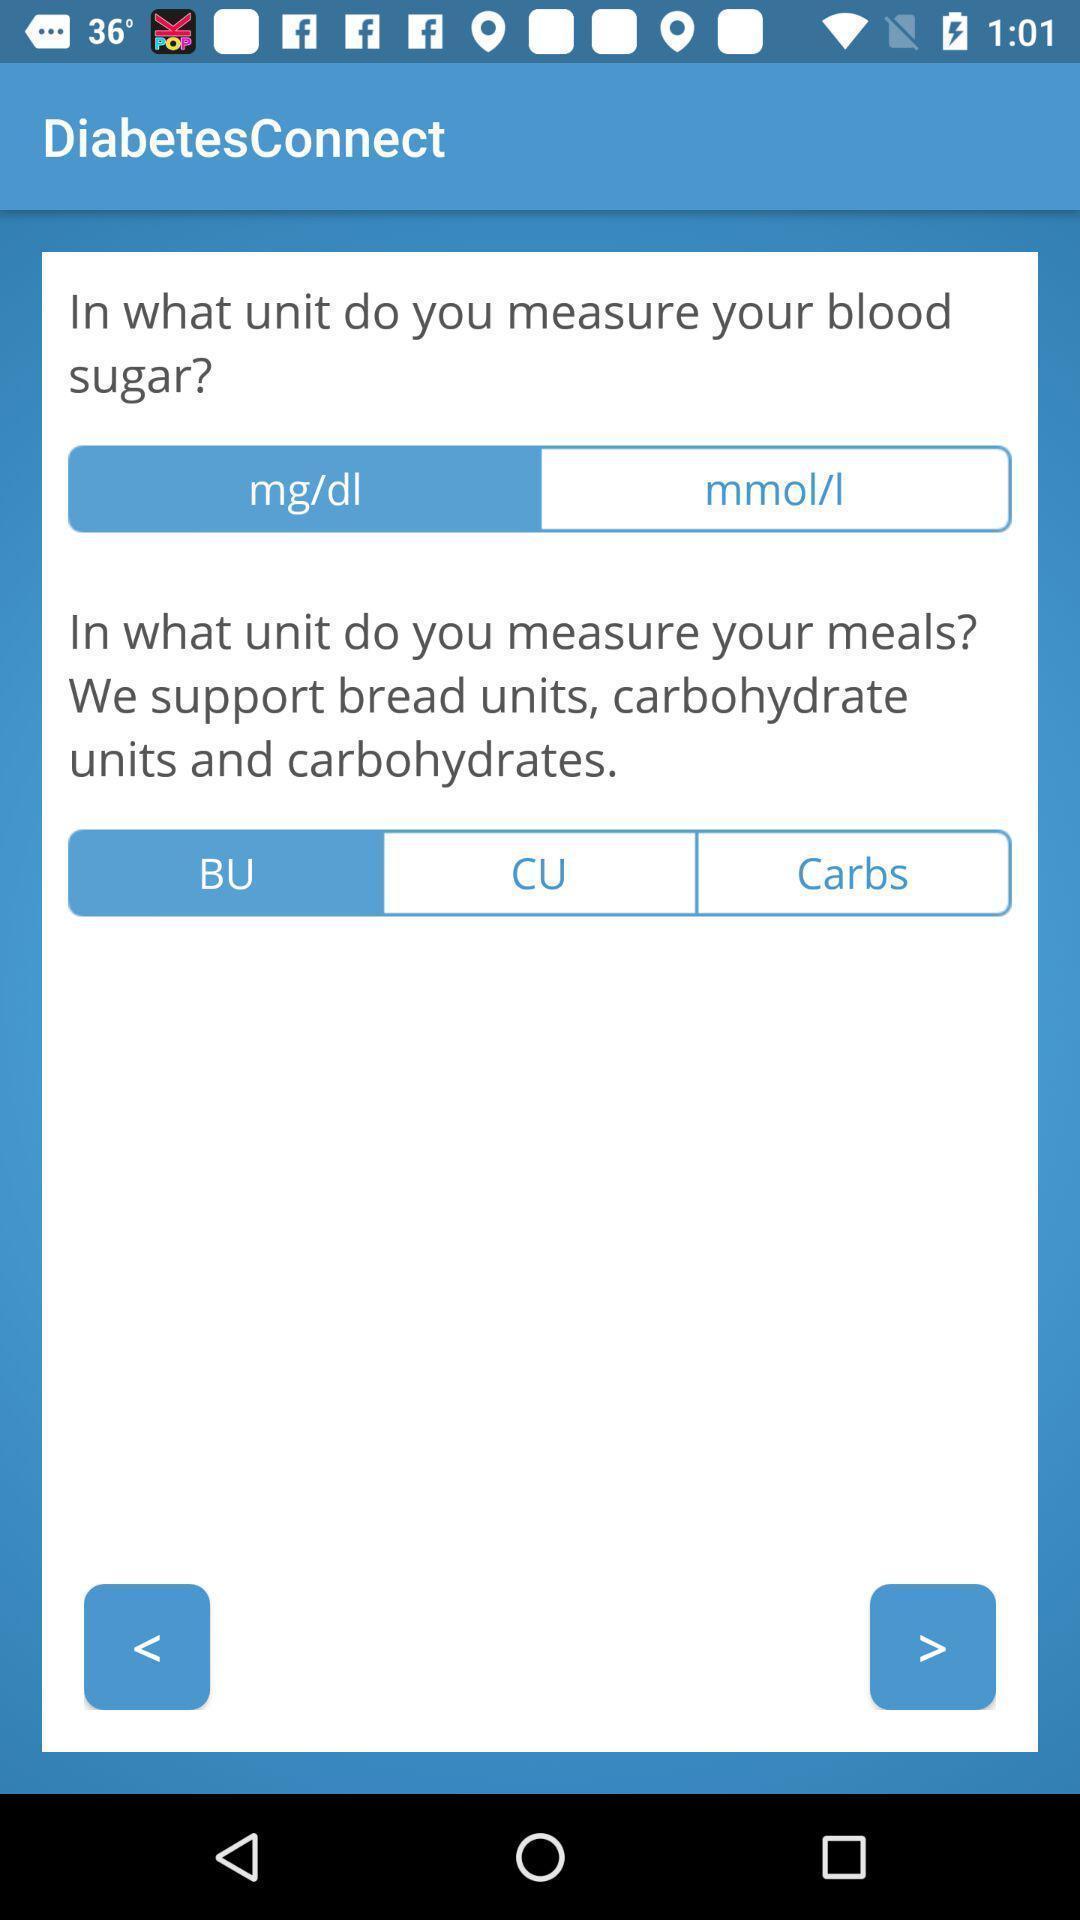Tell me about the visual elements in this screen capture. Page shows the diabetes measuring units on health app. 